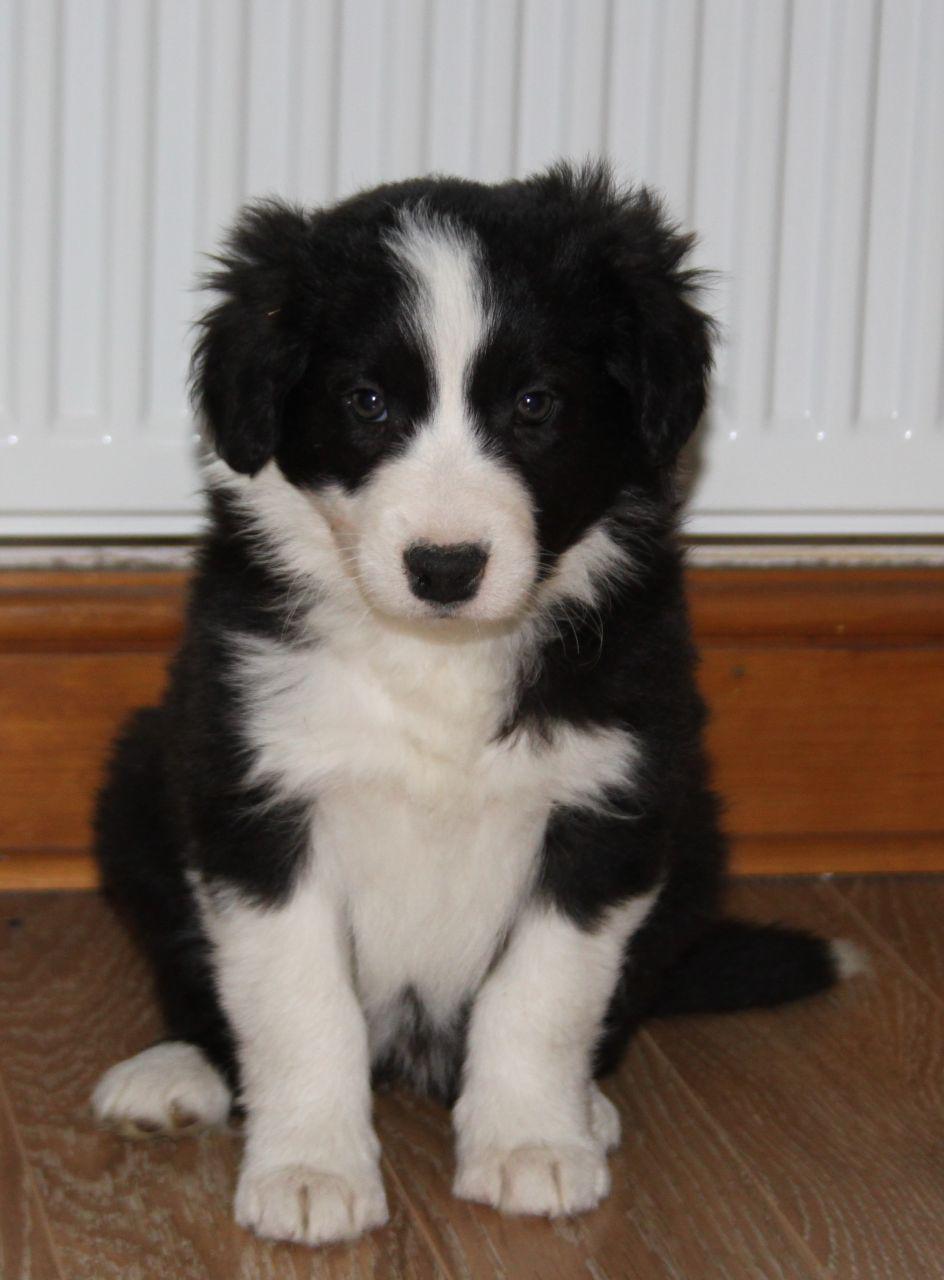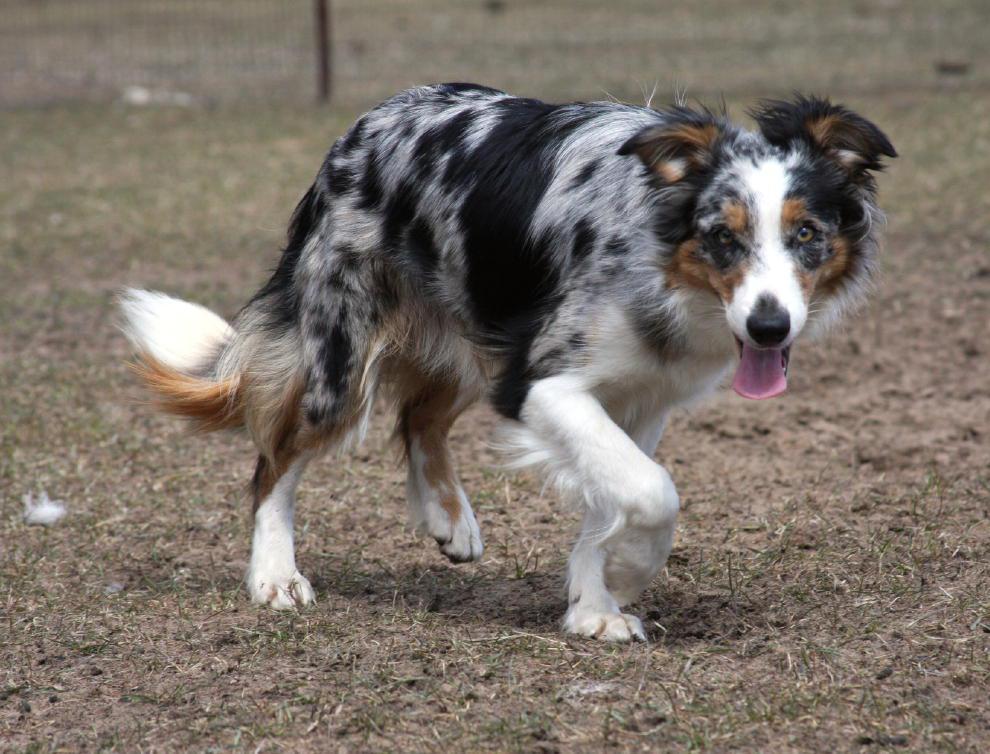The first image is the image on the left, the second image is the image on the right. For the images displayed, is the sentence "a dog is looking at the cameral with a brick wall behind it" factually correct? Answer yes or no. No. The first image is the image on the left, the second image is the image on the right. For the images displayed, is the sentence "A black and white dog with black spots is standing on the ground outside." factually correct? Answer yes or no. Yes. 